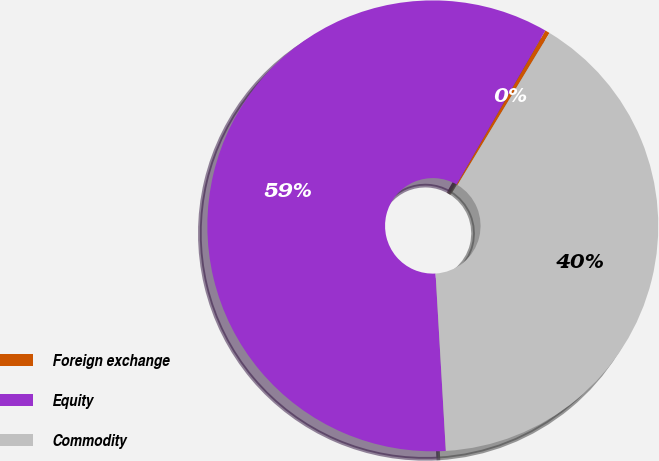Convert chart. <chart><loc_0><loc_0><loc_500><loc_500><pie_chart><fcel>Foreign exchange<fcel>Equity<fcel>Commodity<nl><fcel>0.34%<fcel>59.24%<fcel>40.42%<nl></chart> 